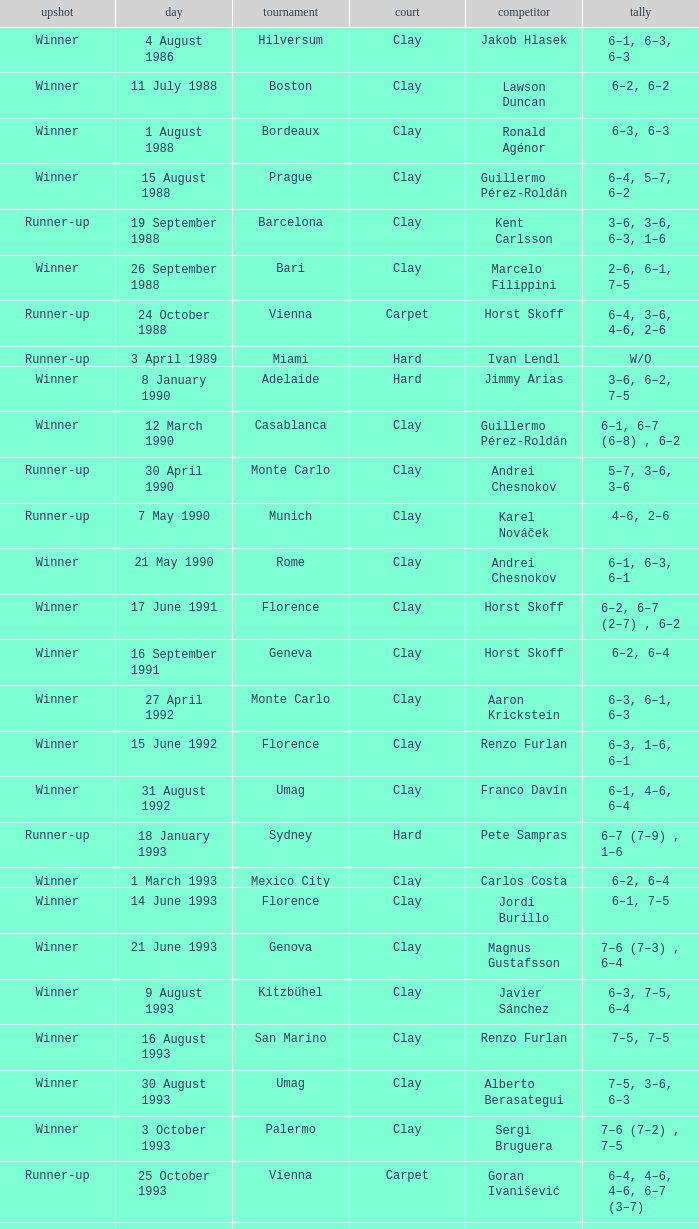What is the score when the championship is rome and the opponent is richard krajicek? 6–2, 6–4, 3–6, 6–3. Could you parse the entire table as a dict? {'header': ['upshot', 'day', 'tournament', 'court', 'competitor', 'tally'], 'rows': [['Winner', '4 August 1986', 'Hilversum', 'Clay', 'Jakob Hlasek', '6–1, 6–3, 6–3'], ['Winner', '11 July 1988', 'Boston', 'Clay', 'Lawson Duncan', '6–2, 6–2'], ['Winner', '1 August 1988', 'Bordeaux', 'Clay', 'Ronald Agénor', '6–3, 6–3'], ['Winner', '15 August 1988', 'Prague', 'Clay', 'Guillermo Pérez-Roldán', '6–4, 5–7, 6–2'], ['Runner-up', '19 September 1988', 'Barcelona', 'Clay', 'Kent Carlsson', '3–6, 3–6, 6–3, 1–6'], ['Winner', '26 September 1988', 'Bari', 'Clay', 'Marcelo Filippini', '2–6, 6–1, 7–5'], ['Runner-up', '24 October 1988', 'Vienna', 'Carpet', 'Horst Skoff', '6–4, 3–6, 4–6, 2–6'], ['Runner-up', '3 April 1989', 'Miami', 'Hard', 'Ivan Lendl', 'W/O'], ['Winner', '8 January 1990', 'Adelaide', 'Hard', 'Jimmy Arias', '3–6, 6–2, 7–5'], ['Winner', '12 March 1990', 'Casablanca', 'Clay', 'Guillermo Pérez-Roldán', '6–1, 6–7 (6–8) , 6–2'], ['Runner-up', '30 April 1990', 'Monte Carlo', 'Clay', 'Andrei Chesnokov', '5–7, 3–6, 3–6'], ['Runner-up', '7 May 1990', 'Munich', 'Clay', 'Karel Nováček', '4–6, 2–6'], ['Winner', '21 May 1990', 'Rome', 'Clay', 'Andrei Chesnokov', '6–1, 6–3, 6–1'], ['Winner', '17 June 1991', 'Florence', 'Clay', 'Horst Skoff', '6–2, 6–7 (2–7) , 6–2'], ['Winner', '16 September 1991', 'Geneva', 'Clay', 'Horst Skoff', '6–2, 6–4'], ['Winner', '27 April 1992', 'Monte Carlo', 'Clay', 'Aaron Krickstein', '6–3, 6–1, 6–3'], ['Winner', '15 June 1992', 'Florence', 'Clay', 'Renzo Furlan', '6–3, 1–6, 6–1'], ['Winner', '31 August 1992', 'Umag', 'Clay', 'Franco Davín', '6–1, 4–6, 6–4'], ['Runner-up', '18 January 1993', 'Sydney', 'Hard', 'Pete Sampras', '6–7 (7–9) , 1–6'], ['Winner', '1 March 1993', 'Mexico City', 'Clay', 'Carlos Costa', '6–2, 6–4'], ['Winner', '14 June 1993', 'Florence', 'Clay', 'Jordi Burillo', '6–1, 7–5'], ['Winner', '21 June 1993', 'Genova', 'Clay', 'Magnus Gustafsson', '7–6 (7–3) , 6–4'], ['Winner', '9 August 1993', 'Kitzbühel', 'Clay', 'Javier Sánchez', '6–3, 7–5, 6–4'], ['Winner', '16 August 1993', 'San Marino', 'Clay', 'Renzo Furlan', '7–5, 7–5'], ['Winner', '30 August 1993', 'Umag', 'Clay', 'Alberto Berasategui', '7–5, 3–6, 6–3'], ['Winner', '3 October 1993', 'Palermo', 'Clay', 'Sergi Bruguera', '7–6 (7–2) , 7–5'], ['Runner-up', '25 October 1993', 'Vienna', 'Carpet', 'Goran Ivanišević', '6–4, 4–6, 4–6, 6–7 (3–7)'], ['Winner', '28 February 1994', 'Mexico City', 'Clay', 'Roberto Jabali', '6–3, 6–1'], ['Winner', '2 May 1994', 'Madrid', 'Clay', 'Sergi Bruguera', '6–2, 3–6, 6–4, 7–5'], ['Winner', '20 June 1994', 'Sankt Pölten', 'Clay', 'Tomás Carbonell', '4–6, 6–2, 6–4'], ['Winner', '6 March 1995', 'Mexico City', 'Clay', 'Fernando Meligeni', '7–6 (7–4) , 7–5'], ['Winner', '10 April 1995', 'Estoril', 'Clay', 'Albert Costa', '6–4, 6–2'], ['Winner', '17 April 1995', 'Barcelona', 'Clay', 'Magnus Larsson', '6–2, 6–1, 6–4'], ['Winner', '1 May 1995', 'Monte Carlo', 'Clay', 'Boris Becker', '4–6, 5–7, 6–1, 7–6 (8–6) , 6–0'], ['Winner', '22 May 1995', 'Rome', 'Clay', 'Sergi Bruguera', '3–6, 7–6 (7–5) , 6–2, 6–3'], ['Winner', '12 June 1995', 'French Open', 'Clay', 'Michael Chang', '7–5, 6–2, 6–4'], ['Winner', '26 June 1995', 'Sankt Pölten', 'Clay', 'Bohdan Ulihrach', '6–3, 3–6, 6–1'], ['Winner', '24 July 1995', 'Stuttgart Outdoor', 'Clay', 'Jan Apell', '6–2, 6–2'], ['Runner-up', '7 August 1995', 'Kitzbühel', 'Clay', 'Albert Costa', '6–4, 4–6, 6–7 (3–7) , 6–2, 4–6'], ['Winner', '14 August 1995', 'San Marino', 'Clay', 'Andrea Gaudenzi', '6–2, 6–0'], ['Winner', '28 August 1995', 'Umag', 'Clay', 'Carlos Costa', '3–6, 7–6 (7–5) , 6–4'], ['Winner', '18 September 1995', 'Bucharest', 'Clay', 'Gilbert Schaller', '6–4, 6–3'], ['Runner-up', '23 October 1995', 'Vienna', 'Carpet', 'Filip Dewulf', '5–7, 2–6, 6–1, 5–7'], ['Winner', '30 October 1995', 'Essen', 'Carpet', 'MaliVai Washington', '7–6 (8–6) , 2–6, 6–3, 6–4'], ['Winner', '11 March 1996', 'Mexico City', 'Clay', 'Jiří Novák', '7–6 (7–3) , 6–2'], ['Winner', '15 April 1996', 'Estoril', 'Clay', 'Andrea Gaudenzi', '7–6 (7–4) , 6–4'], ['Winner', '22 April 1996', 'Barcelona', 'Clay', 'Marcelo Ríos', '6–3, 4–6, 6–4, 6–1'], ['Winner', '29 April 1996', 'Monte Carlo', 'Clay', 'Albert Costa', '6–3, 5–7, 4–6, 6–3, 6–2'], ['Winner', '20 May 1996', 'Rome', 'Clay', 'Richard Krajicek', '6–2, 6–4, 3–6, 6–3'], ['Winner', '22 July 1996', 'Stuttgart Outdoor', 'Clay', 'Yevgeny Kafelnikov', '6–2, 6–2, 6–4'], ['Winner', '16 September 1996', 'Bogotá', 'Clay', 'Nicolás Lapentti', '6–7 (6–8) , 6–2, 6–3'], ['Winner', '17 February 1997', 'Dubai', 'Hard', 'Goran Ivanišević', '7–5, 7–6 (7–3)'], ['Winner', '31 March 1997', 'Miami', 'Hard', 'Sergi Bruguera', '7–6 (8–6) , 6–3, 6–1'], ['Runner-up', '11 August 1997', 'Cincinnati', 'Hard', 'Pete Sampras', '3–6, 4–6'], ['Runner-up', '13 April 1998', 'Estoril', 'Clay', 'Alberto Berasategui', '6–3, 1–6, 3–6']]} 